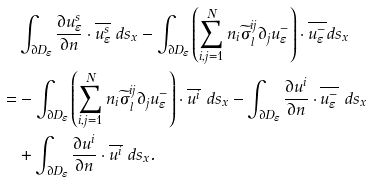Convert formula to latex. <formula><loc_0><loc_0><loc_500><loc_500>& \int _ { \partial D _ { \varepsilon } } \frac { \partial u _ { \varepsilon } ^ { s } } { \partial n } \cdot \overline { u _ { \varepsilon } ^ { s } } \ d s _ { x } - \int _ { \partial D _ { \varepsilon } } \left ( \sum _ { i , j = 1 } ^ { N } n _ { i } \widetilde { \sigma } _ { l } ^ { i j } \partial _ { j } u _ { \varepsilon } ^ { - } \right ) \cdot \overline { u _ { \varepsilon } ^ { - } } d s _ { x } \\ = & - \int _ { \partial D _ { \varepsilon } } \left ( \sum _ { i , j = 1 } ^ { N } n _ { i } \widetilde { \sigma } _ { l } ^ { i j } \partial _ { j } u _ { \varepsilon } ^ { - } \right ) \cdot \overline { u ^ { i } } \ d s _ { x } - \int _ { \partial D _ { \varepsilon } } \frac { \partial u ^ { i } } { \partial n } \cdot \overline { u _ { \varepsilon } ^ { - } } \ d s _ { x } \\ & + \int _ { \partial D _ { \varepsilon } } \frac { \partial u ^ { i } } { \partial n } \cdot \overline { u ^ { i } } \ d s _ { x } .</formula> 